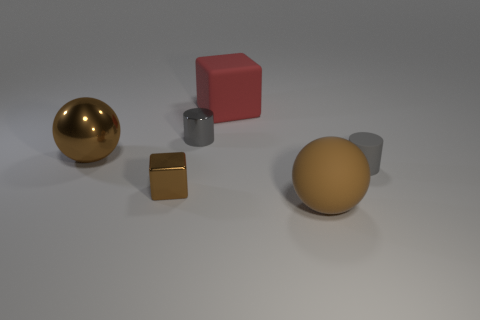What number of objects are blocks in front of the big brown shiny object or matte cylinders?
Your response must be concise. 2. Is the number of shiny cylinders that are in front of the large brown metal object greater than the number of small brown metallic objects that are behind the big red matte thing?
Offer a very short reply. No. How many metallic objects are either big spheres or big red cubes?
Your answer should be very brief. 1. What is the material of the cube that is the same color as the large metal sphere?
Your response must be concise. Metal. Are there fewer tiny things behind the metal block than large brown metal objects that are behind the red rubber thing?
Provide a short and direct response. No. How many objects are either gray matte blocks or large things behind the tiny brown shiny cube?
Keep it short and to the point. 2. What is the material of the cube that is the same size as the shiny sphere?
Your answer should be very brief. Rubber. Do the big cube and the small brown thing have the same material?
Ensure brevity in your answer.  No. There is a large thing that is to the right of the small metallic block and behind the large matte ball; what color is it?
Offer a terse response. Red. There is a block that is on the right side of the small block; is its color the same as the matte ball?
Keep it short and to the point. No. 